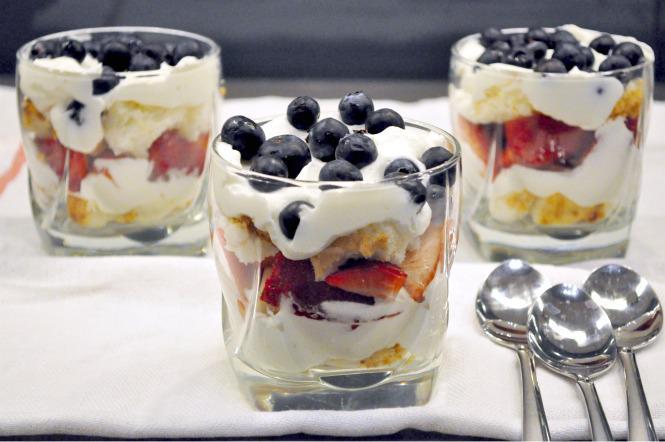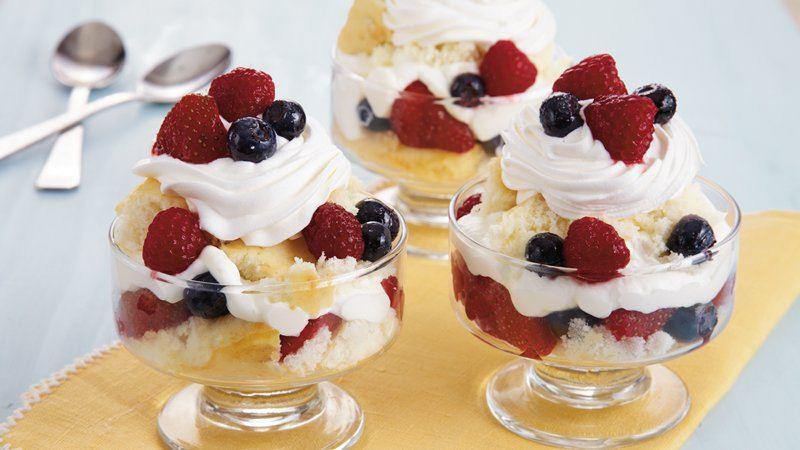The first image is the image on the left, the second image is the image on the right. Considering the images on both sides, is "An image shows single-serve desserts garnished with blueberries and red raspberries." valid? Answer yes or no. Yes. The first image is the image on the left, the second image is the image on the right. Assess this claim about the two images: "Each image is a display of at least three individual trifle desserts that are topped with pieces of whole fruit.". Correct or not? Answer yes or no. Yes. 